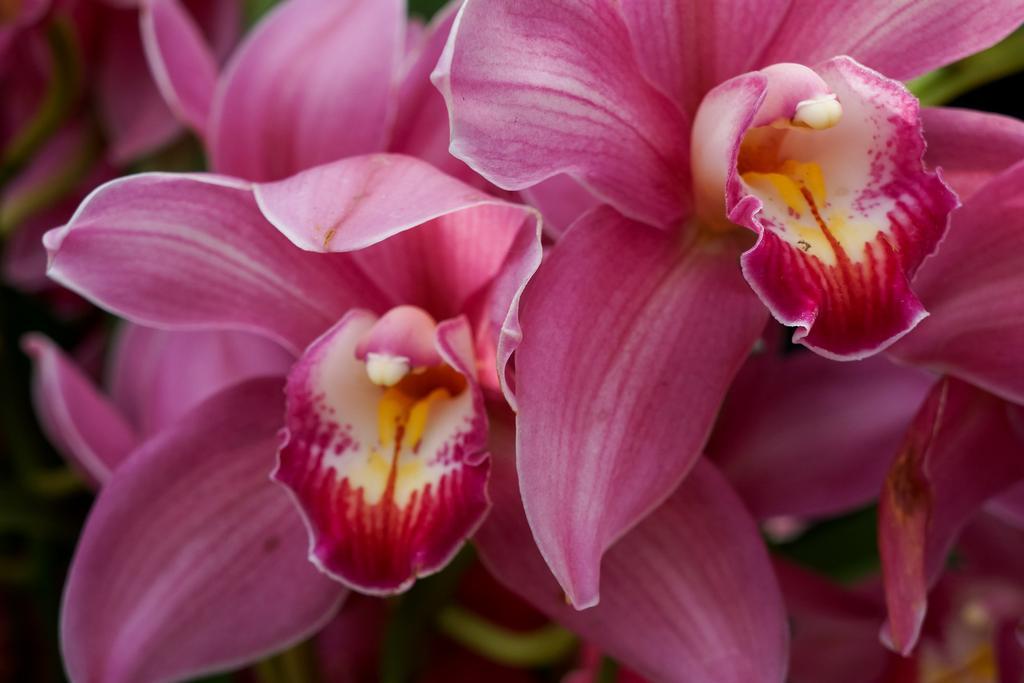Could you give a brief overview of what you see in this image? In this image I can see pink color flowers and plants. This image is taken may be in a garden. 